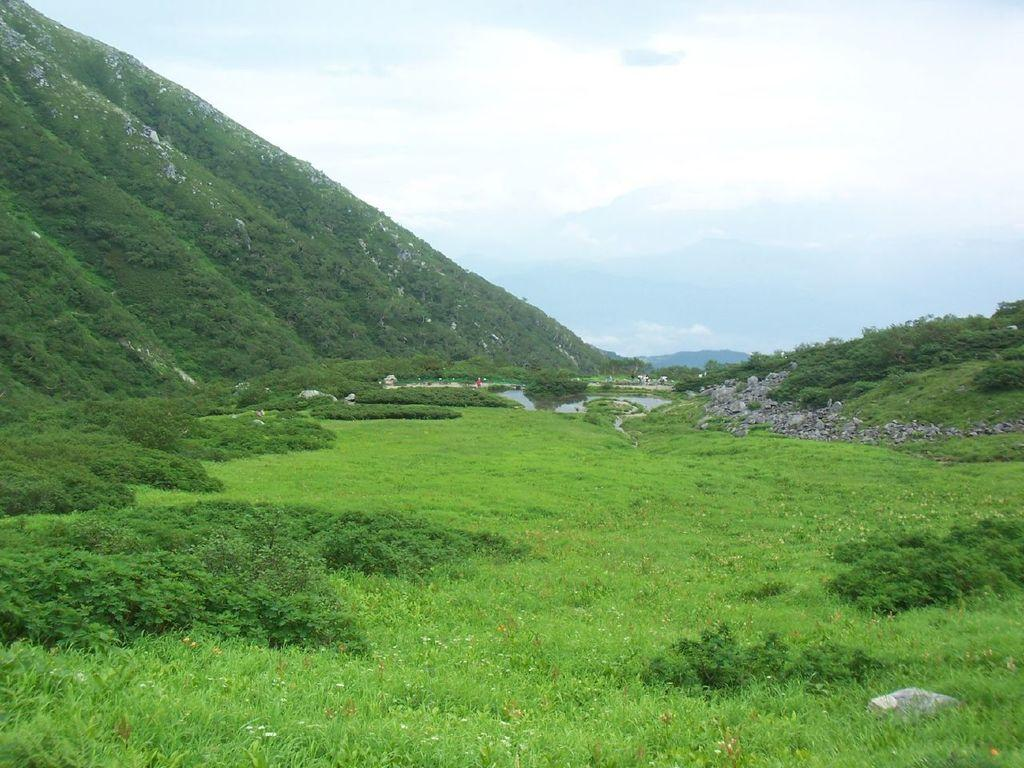What type of vegetation is at the bottom of the image? There is grass at the bottom of the image. What can be seen on the left side of the image? There are trees on a hill on the left side of the image. What is visible at the top of the image? The sky is visible at the top of the image. How would you describe the sky in the image? The sky appears to be cloudy. What page is the girl reading in the image? There is no girl or page present in the image; it features grass, trees, and a cloudy sky. 